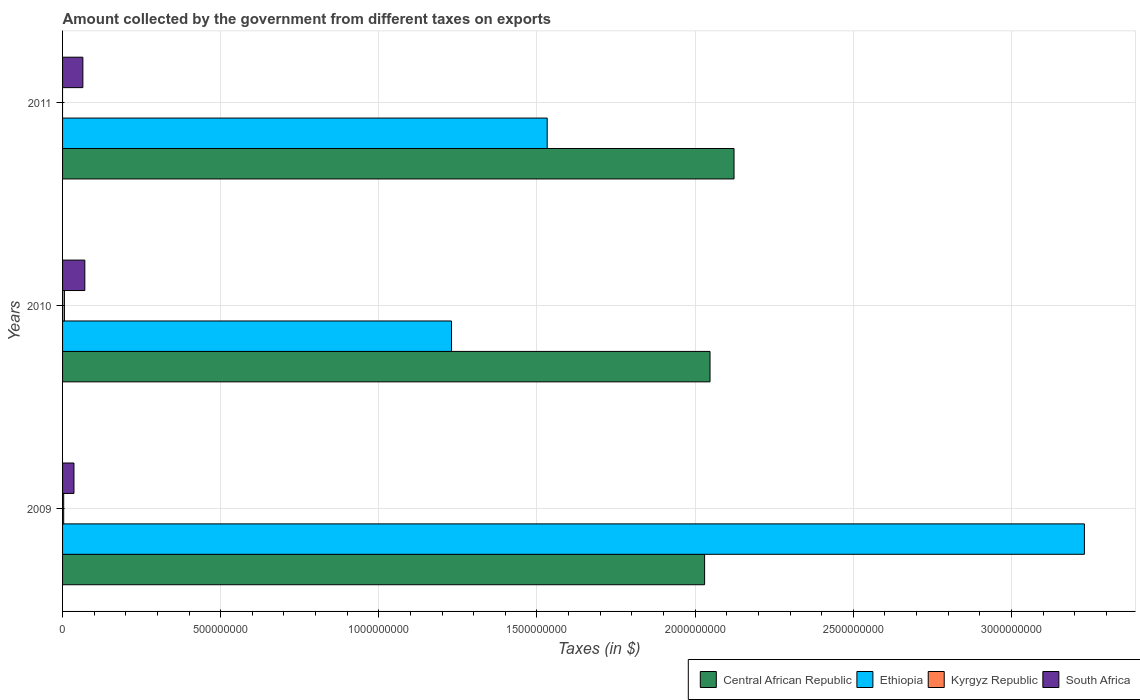How many groups of bars are there?
Keep it short and to the point. 3. What is the label of the 2nd group of bars from the top?
Your answer should be compact. 2010. What is the amount collected by the government from taxes on exports in South Africa in 2009?
Provide a succinct answer. 3.60e+07. Across all years, what is the maximum amount collected by the government from taxes on exports in South Africa?
Offer a very short reply. 7.04e+07. Across all years, what is the minimum amount collected by the government from taxes on exports in Kyrgyz Republic?
Ensure brevity in your answer.  0. In which year was the amount collected by the government from taxes on exports in Ethiopia maximum?
Offer a very short reply. 2009. What is the total amount collected by the government from taxes on exports in South Africa in the graph?
Your answer should be very brief. 1.71e+08. What is the difference between the amount collected by the government from taxes on exports in South Africa in 2010 and that in 2011?
Keep it short and to the point. 6.16e+06. What is the difference between the amount collected by the government from taxes on exports in Central African Republic in 2009 and the amount collected by the government from taxes on exports in South Africa in 2011?
Keep it short and to the point. 1.97e+09. What is the average amount collected by the government from taxes on exports in South Africa per year?
Give a very brief answer. 5.69e+07. In the year 2011, what is the difference between the amount collected by the government from taxes on exports in South Africa and amount collected by the government from taxes on exports in Central African Republic?
Provide a short and direct response. -2.06e+09. What is the ratio of the amount collected by the government from taxes on exports in Central African Republic in 2010 to that in 2011?
Your answer should be compact. 0.96. Is the amount collected by the government from taxes on exports in Kyrgyz Republic in 2009 less than that in 2010?
Give a very brief answer. Yes. What is the difference between the highest and the second highest amount collected by the government from taxes on exports in Central African Republic?
Keep it short and to the point. 7.59e+07. What is the difference between the highest and the lowest amount collected by the government from taxes on exports in Kyrgyz Republic?
Give a very brief answer. 5.91e+06. Is it the case that in every year, the sum of the amount collected by the government from taxes on exports in Kyrgyz Republic and amount collected by the government from taxes on exports in Ethiopia is greater than the sum of amount collected by the government from taxes on exports in South Africa and amount collected by the government from taxes on exports in Central African Republic?
Offer a very short reply. No. Are all the bars in the graph horizontal?
Offer a very short reply. Yes. How many years are there in the graph?
Your response must be concise. 3. What is the difference between two consecutive major ticks on the X-axis?
Make the answer very short. 5.00e+08. Does the graph contain grids?
Give a very brief answer. Yes. Where does the legend appear in the graph?
Make the answer very short. Bottom right. What is the title of the graph?
Provide a short and direct response. Amount collected by the government from different taxes on exports. What is the label or title of the X-axis?
Give a very brief answer. Taxes (in $). What is the Taxes (in $) of Central African Republic in 2009?
Your answer should be very brief. 2.03e+09. What is the Taxes (in $) of Ethiopia in 2009?
Ensure brevity in your answer.  3.23e+09. What is the Taxes (in $) in Kyrgyz Republic in 2009?
Keep it short and to the point. 3.56e+06. What is the Taxes (in $) of South Africa in 2009?
Make the answer very short. 3.60e+07. What is the Taxes (in $) in Central African Republic in 2010?
Ensure brevity in your answer.  2.05e+09. What is the Taxes (in $) in Ethiopia in 2010?
Your answer should be compact. 1.23e+09. What is the Taxes (in $) in Kyrgyz Republic in 2010?
Your answer should be very brief. 5.91e+06. What is the Taxes (in $) of South Africa in 2010?
Make the answer very short. 7.04e+07. What is the Taxes (in $) of Central African Republic in 2011?
Offer a terse response. 2.12e+09. What is the Taxes (in $) in Ethiopia in 2011?
Provide a succinct answer. 1.53e+09. What is the Taxes (in $) in South Africa in 2011?
Ensure brevity in your answer.  6.42e+07. Across all years, what is the maximum Taxes (in $) of Central African Republic?
Your response must be concise. 2.12e+09. Across all years, what is the maximum Taxes (in $) in Ethiopia?
Offer a terse response. 3.23e+09. Across all years, what is the maximum Taxes (in $) of Kyrgyz Republic?
Make the answer very short. 5.91e+06. Across all years, what is the maximum Taxes (in $) of South Africa?
Provide a succinct answer. 7.04e+07. Across all years, what is the minimum Taxes (in $) of Central African Republic?
Provide a succinct answer. 2.03e+09. Across all years, what is the minimum Taxes (in $) in Ethiopia?
Keep it short and to the point. 1.23e+09. Across all years, what is the minimum Taxes (in $) of South Africa?
Offer a terse response. 3.60e+07. What is the total Taxes (in $) in Central African Republic in the graph?
Offer a very short reply. 6.20e+09. What is the total Taxes (in $) of Ethiopia in the graph?
Ensure brevity in your answer.  5.99e+09. What is the total Taxes (in $) in Kyrgyz Republic in the graph?
Offer a very short reply. 9.48e+06. What is the total Taxes (in $) in South Africa in the graph?
Keep it short and to the point. 1.71e+08. What is the difference between the Taxes (in $) in Central African Republic in 2009 and that in 2010?
Your answer should be very brief. -1.71e+07. What is the difference between the Taxes (in $) of Ethiopia in 2009 and that in 2010?
Offer a very short reply. 2.00e+09. What is the difference between the Taxes (in $) of Kyrgyz Republic in 2009 and that in 2010?
Offer a terse response. -2.35e+06. What is the difference between the Taxes (in $) in South Africa in 2009 and that in 2010?
Your response must be concise. -3.44e+07. What is the difference between the Taxes (in $) in Central African Republic in 2009 and that in 2011?
Offer a terse response. -9.30e+07. What is the difference between the Taxes (in $) of Ethiopia in 2009 and that in 2011?
Ensure brevity in your answer.  1.70e+09. What is the difference between the Taxes (in $) of South Africa in 2009 and that in 2011?
Your answer should be compact. -2.82e+07. What is the difference between the Taxes (in $) in Central African Republic in 2010 and that in 2011?
Offer a very short reply. -7.59e+07. What is the difference between the Taxes (in $) of Ethiopia in 2010 and that in 2011?
Give a very brief answer. -3.03e+08. What is the difference between the Taxes (in $) in South Africa in 2010 and that in 2011?
Your answer should be very brief. 6.16e+06. What is the difference between the Taxes (in $) of Central African Republic in 2009 and the Taxes (in $) of Ethiopia in 2010?
Offer a terse response. 8.00e+08. What is the difference between the Taxes (in $) in Central African Republic in 2009 and the Taxes (in $) in Kyrgyz Republic in 2010?
Make the answer very short. 2.02e+09. What is the difference between the Taxes (in $) in Central African Republic in 2009 and the Taxes (in $) in South Africa in 2010?
Your answer should be compact. 1.96e+09. What is the difference between the Taxes (in $) in Ethiopia in 2009 and the Taxes (in $) in Kyrgyz Republic in 2010?
Offer a terse response. 3.22e+09. What is the difference between the Taxes (in $) in Ethiopia in 2009 and the Taxes (in $) in South Africa in 2010?
Ensure brevity in your answer.  3.16e+09. What is the difference between the Taxes (in $) of Kyrgyz Republic in 2009 and the Taxes (in $) of South Africa in 2010?
Your response must be concise. -6.68e+07. What is the difference between the Taxes (in $) of Central African Republic in 2009 and the Taxes (in $) of Ethiopia in 2011?
Ensure brevity in your answer.  4.98e+08. What is the difference between the Taxes (in $) in Central African Republic in 2009 and the Taxes (in $) in South Africa in 2011?
Your answer should be compact. 1.97e+09. What is the difference between the Taxes (in $) of Ethiopia in 2009 and the Taxes (in $) of South Africa in 2011?
Offer a terse response. 3.17e+09. What is the difference between the Taxes (in $) in Kyrgyz Republic in 2009 and the Taxes (in $) in South Africa in 2011?
Provide a short and direct response. -6.07e+07. What is the difference between the Taxes (in $) of Central African Republic in 2010 and the Taxes (in $) of Ethiopia in 2011?
Keep it short and to the point. 5.15e+08. What is the difference between the Taxes (in $) of Central African Republic in 2010 and the Taxes (in $) of South Africa in 2011?
Your answer should be compact. 1.98e+09. What is the difference between the Taxes (in $) in Ethiopia in 2010 and the Taxes (in $) in South Africa in 2011?
Provide a short and direct response. 1.17e+09. What is the difference between the Taxes (in $) of Kyrgyz Republic in 2010 and the Taxes (in $) of South Africa in 2011?
Ensure brevity in your answer.  -5.83e+07. What is the average Taxes (in $) in Central African Republic per year?
Give a very brief answer. 2.07e+09. What is the average Taxes (in $) in Ethiopia per year?
Make the answer very short. 2.00e+09. What is the average Taxes (in $) of Kyrgyz Republic per year?
Provide a succinct answer. 3.16e+06. What is the average Taxes (in $) of South Africa per year?
Provide a succinct answer. 5.69e+07. In the year 2009, what is the difference between the Taxes (in $) in Central African Republic and Taxes (in $) in Ethiopia?
Provide a short and direct response. -1.20e+09. In the year 2009, what is the difference between the Taxes (in $) in Central African Republic and Taxes (in $) in Kyrgyz Republic?
Your answer should be compact. 2.03e+09. In the year 2009, what is the difference between the Taxes (in $) in Central African Republic and Taxes (in $) in South Africa?
Ensure brevity in your answer.  1.99e+09. In the year 2009, what is the difference between the Taxes (in $) of Ethiopia and Taxes (in $) of Kyrgyz Republic?
Offer a very short reply. 3.23e+09. In the year 2009, what is the difference between the Taxes (in $) in Ethiopia and Taxes (in $) in South Africa?
Provide a short and direct response. 3.19e+09. In the year 2009, what is the difference between the Taxes (in $) in Kyrgyz Republic and Taxes (in $) in South Africa?
Offer a terse response. -3.24e+07. In the year 2010, what is the difference between the Taxes (in $) in Central African Republic and Taxes (in $) in Ethiopia?
Your response must be concise. 8.17e+08. In the year 2010, what is the difference between the Taxes (in $) of Central African Republic and Taxes (in $) of Kyrgyz Republic?
Make the answer very short. 2.04e+09. In the year 2010, what is the difference between the Taxes (in $) in Central African Republic and Taxes (in $) in South Africa?
Provide a short and direct response. 1.98e+09. In the year 2010, what is the difference between the Taxes (in $) of Ethiopia and Taxes (in $) of Kyrgyz Republic?
Provide a short and direct response. 1.22e+09. In the year 2010, what is the difference between the Taxes (in $) in Ethiopia and Taxes (in $) in South Africa?
Keep it short and to the point. 1.16e+09. In the year 2010, what is the difference between the Taxes (in $) in Kyrgyz Republic and Taxes (in $) in South Africa?
Your answer should be very brief. -6.45e+07. In the year 2011, what is the difference between the Taxes (in $) of Central African Republic and Taxes (in $) of Ethiopia?
Make the answer very short. 5.91e+08. In the year 2011, what is the difference between the Taxes (in $) of Central African Republic and Taxes (in $) of South Africa?
Your answer should be very brief. 2.06e+09. In the year 2011, what is the difference between the Taxes (in $) in Ethiopia and Taxes (in $) in South Africa?
Offer a terse response. 1.47e+09. What is the ratio of the Taxes (in $) in Central African Republic in 2009 to that in 2010?
Offer a very short reply. 0.99. What is the ratio of the Taxes (in $) in Ethiopia in 2009 to that in 2010?
Your answer should be very brief. 2.63. What is the ratio of the Taxes (in $) in Kyrgyz Republic in 2009 to that in 2010?
Provide a succinct answer. 0.6. What is the ratio of the Taxes (in $) of South Africa in 2009 to that in 2010?
Give a very brief answer. 0.51. What is the ratio of the Taxes (in $) in Central African Republic in 2009 to that in 2011?
Make the answer very short. 0.96. What is the ratio of the Taxes (in $) of Ethiopia in 2009 to that in 2011?
Keep it short and to the point. 2.11. What is the ratio of the Taxes (in $) of South Africa in 2009 to that in 2011?
Provide a short and direct response. 0.56. What is the ratio of the Taxes (in $) in Ethiopia in 2010 to that in 2011?
Provide a succinct answer. 0.8. What is the ratio of the Taxes (in $) of South Africa in 2010 to that in 2011?
Your response must be concise. 1.1. What is the difference between the highest and the second highest Taxes (in $) in Central African Republic?
Your response must be concise. 7.59e+07. What is the difference between the highest and the second highest Taxes (in $) in Ethiopia?
Provide a succinct answer. 1.70e+09. What is the difference between the highest and the second highest Taxes (in $) in South Africa?
Provide a short and direct response. 6.16e+06. What is the difference between the highest and the lowest Taxes (in $) of Central African Republic?
Your answer should be very brief. 9.30e+07. What is the difference between the highest and the lowest Taxes (in $) in Ethiopia?
Offer a terse response. 2.00e+09. What is the difference between the highest and the lowest Taxes (in $) of Kyrgyz Republic?
Provide a short and direct response. 5.91e+06. What is the difference between the highest and the lowest Taxes (in $) of South Africa?
Offer a terse response. 3.44e+07. 